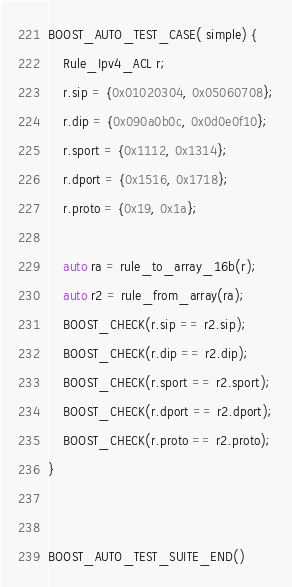Convert code to text. <code><loc_0><loc_0><loc_500><loc_500><_C++_>
BOOST_AUTO_TEST_CASE( simple) {
	Rule_Ipv4_ACL r;
	r.sip = {0x01020304, 0x05060708};
	r.dip = {0x090a0b0c, 0x0d0e0f10};
	r.sport = {0x1112, 0x1314};
	r.dport = {0x1516, 0x1718};
	r.proto = {0x19, 0x1a};

	auto ra = rule_to_array_16b(r);
	auto r2 = rule_from_array(ra);
	BOOST_CHECK(r.sip == r2.sip);
	BOOST_CHECK(r.dip == r2.dip);
	BOOST_CHECK(r.sport == r2.sport);
	BOOST_CHECK(r.dport == r2.dport);
	BOOST_CHECK(r.proto == r2.proto);
}


BOOST_AUTO_TEST_SUITE_END()
</code> 